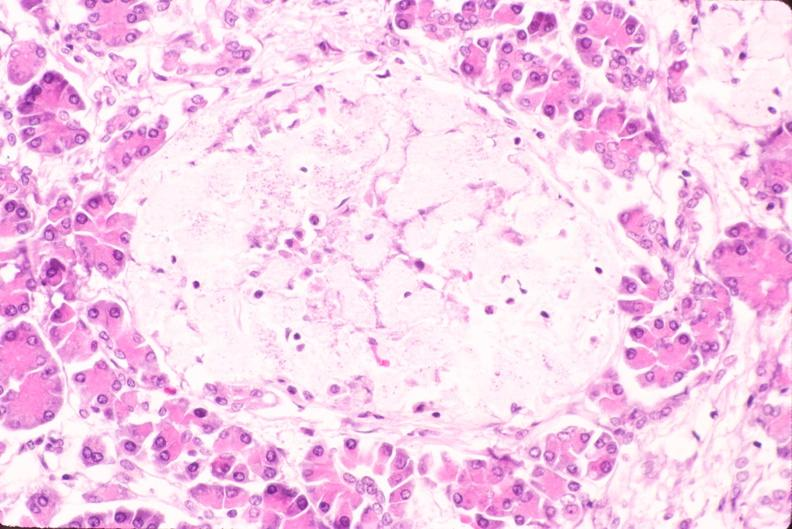s heart present?
Answer the question using a single word or phrase. No 